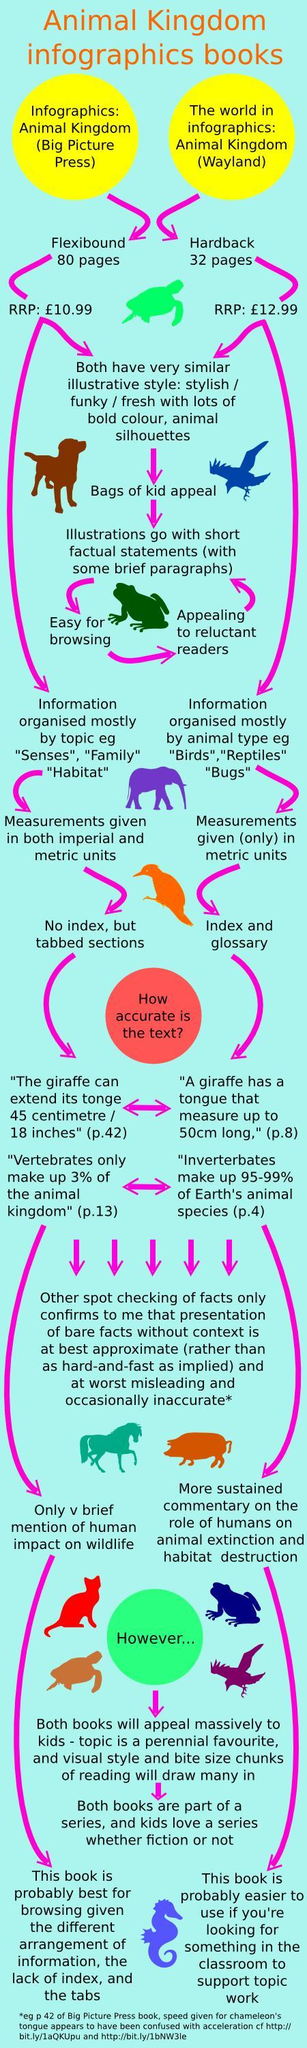What is the price of book published by Big Picture Press in pounds, 32, 10.99, or 12.99?
Answer the question with a short phrase. 10.99 How many pages does the Hard back cover of Animal Kingdom have, 80, 32, or 10? 32 